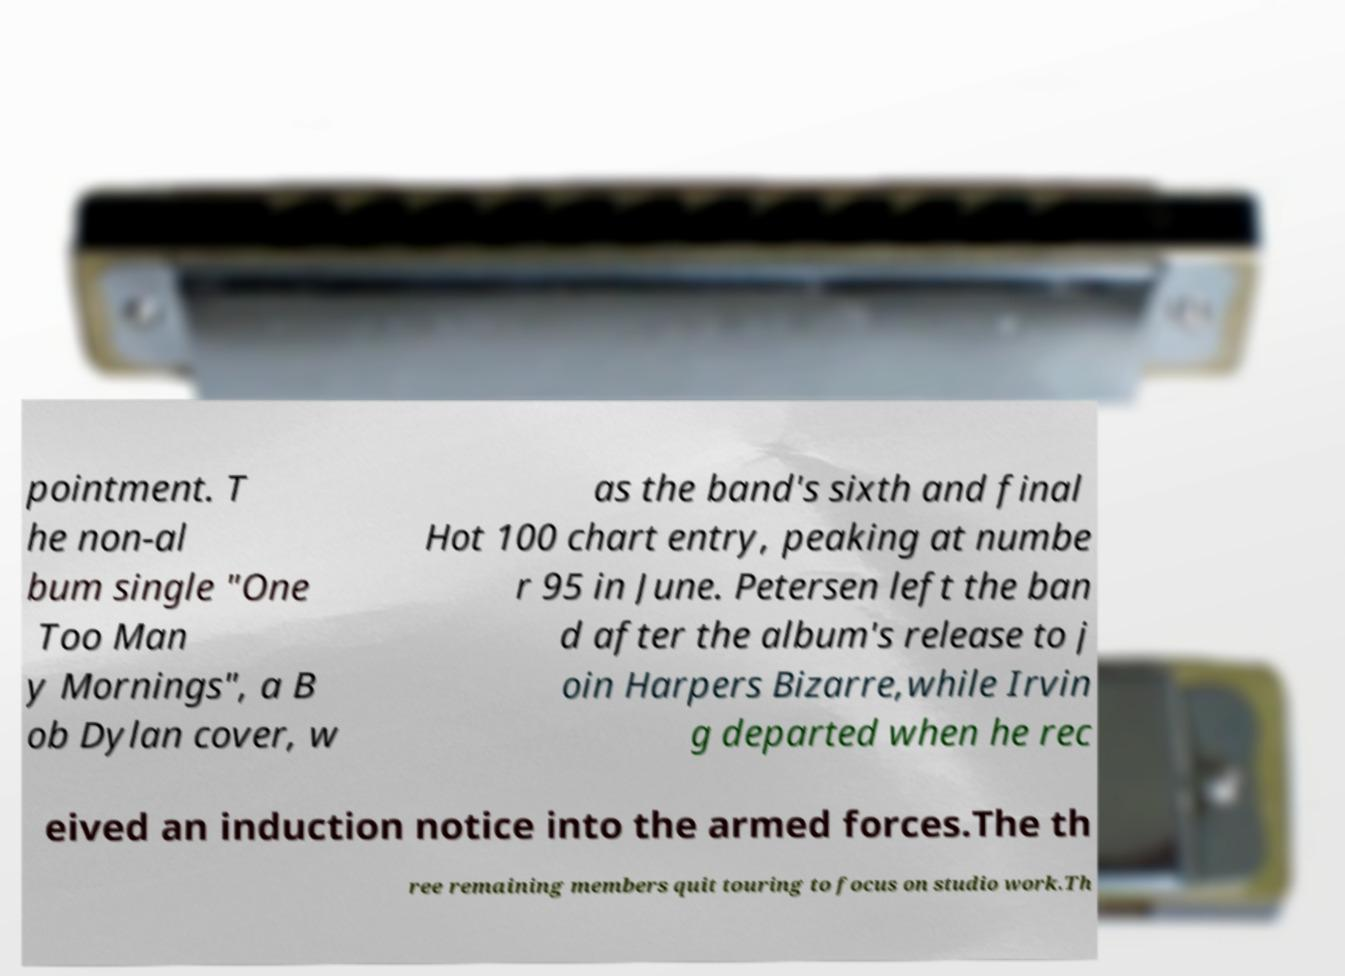Could you assist in decoding the text presented in this image and type it out clearly? pointment. T he non-al bum single "One Too Man y Mornings", a B ob Dylan cover, w as the band's sixth and final Hot 100 chart entry, peaking at numbe r 95 in June. Petersen left the ban d after the album's release to j oin Harpers Bizarre,while Irvin g departed when he rec eived an induction notice into the armed forces.The th ree remaining members quit touring to focus on studio work.Th 